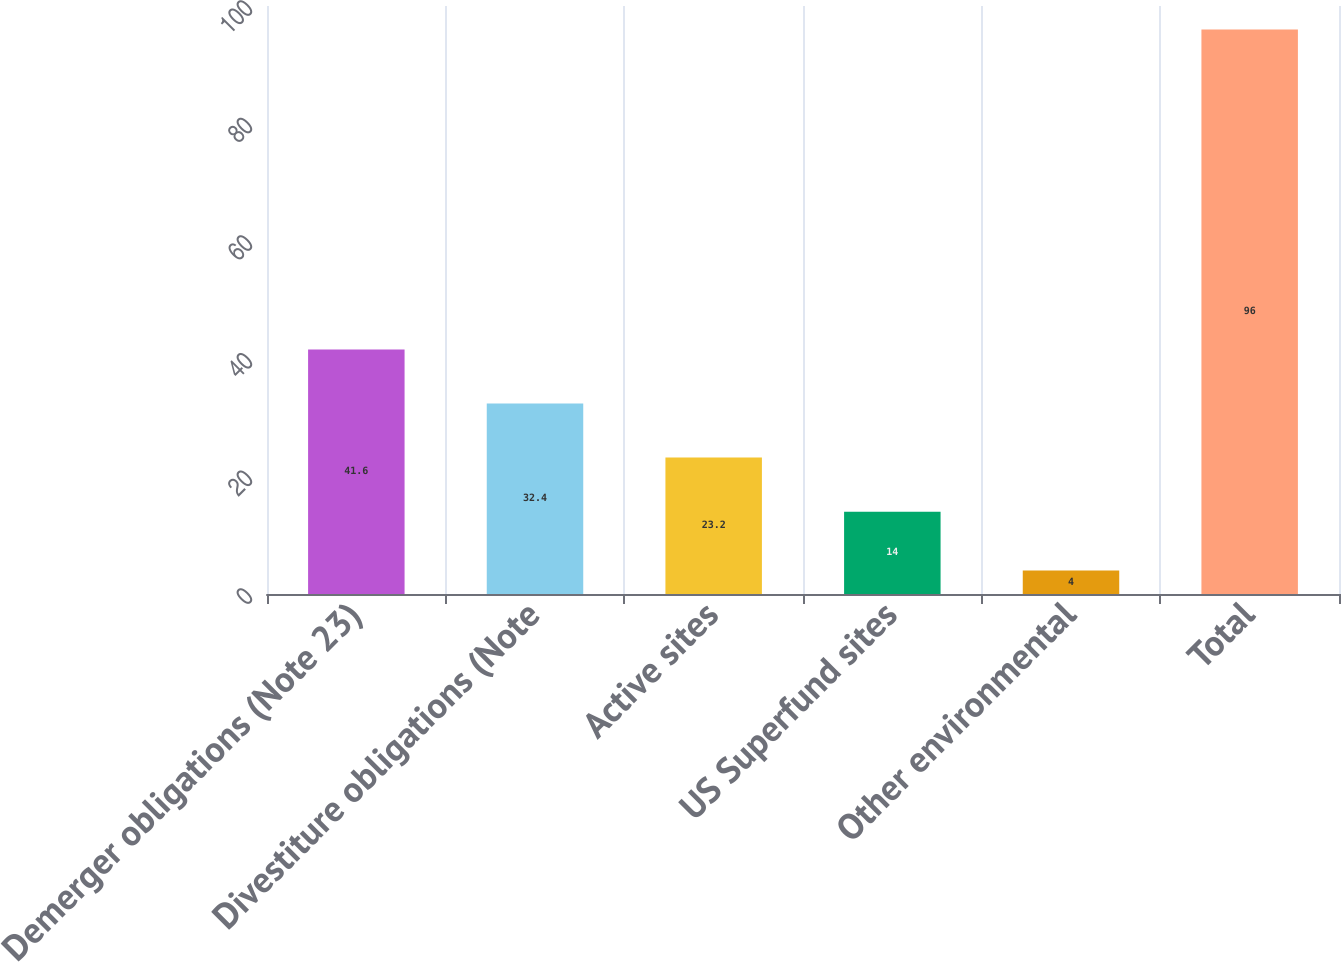Convert chart to OTSL. <chart><loc_0><loc_0><loc_500><loc_500><bar_chart><fcel>Demerger obligations (Note 23)<fcel>Divestiture obligations (Note<fcel>Active sites<fcel>US Superfund sites<fcel>Other environmental<fcel>Total<nl><fcel>41.6<fcel>32.4<fcel>23.2<fcel>14<fcel>4<fcel>96<nl></chart> 